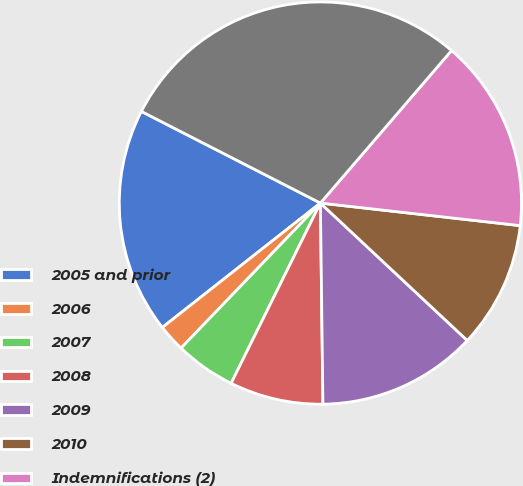Convert chart. <chart><loc_0><loc_0><loc_500><loc_500><pie_chart><fcel>2005 and prior<fcel>2006<fcel>2007<fcel>2008<fcel>2009<fcel>2010<fcel>Indemnifications (2)<fcel>Total<nl><fcel>18.14%<fcel>2.21%<fcel>4.86%<fcel>7.52%<fcel>12.83%<fcel>10.18%<fcel>15.49%<fcel>28.77%<nl></chart> 